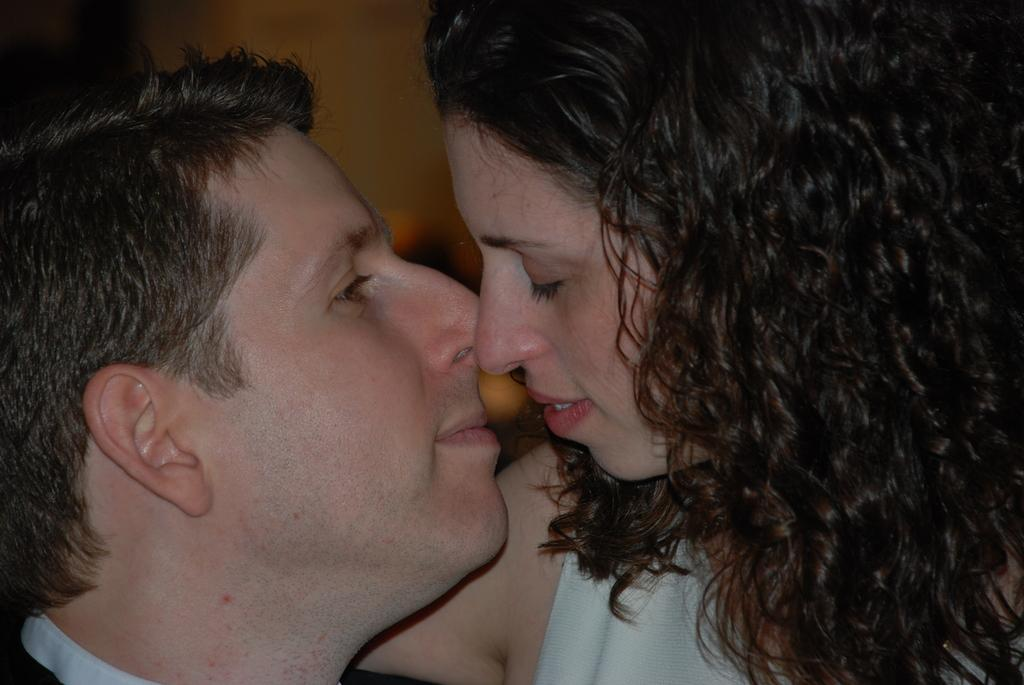How many people are present in the image? There is a man and a woman in the image. Can you describe the background of the image? The background of the image is blurry. What type of boat can be seen in the background of the image? There is no boat present in the image; the background is blurry. What game are the man and woman playing in the image? There is no game being played in the image; it only shows a man and a woman. 